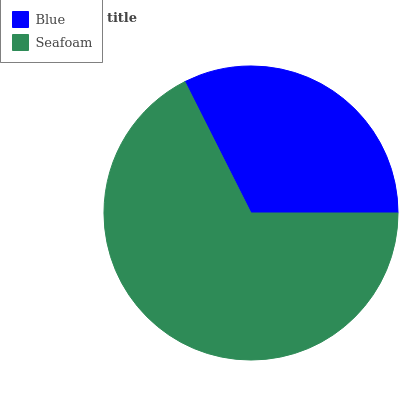Is Blue the minimum?
Answer yes or no. Yes. Is Seafoam the maximum?
Answer yes or no. Yes. Is Seafoam the minimum?
Answer yes or no. No. Is Seafoam greater than Blue?
Answer yes or no. Yes. Is Blue less than Seafoam?
Answer yes or no. Yes. Is Blue greater than Seafoam?
Answer yes or no. No. Is Seafoam less than Blue?
Answer yes or no. No. Is Seafoam the high median?
Answer yes or no. Yes. Is Blue the low median?
Answer yes or no. Yes. Is Blue the high median?
Answer yes or no. No. Is Seafoam the low median?
Answer yes or no. No. 